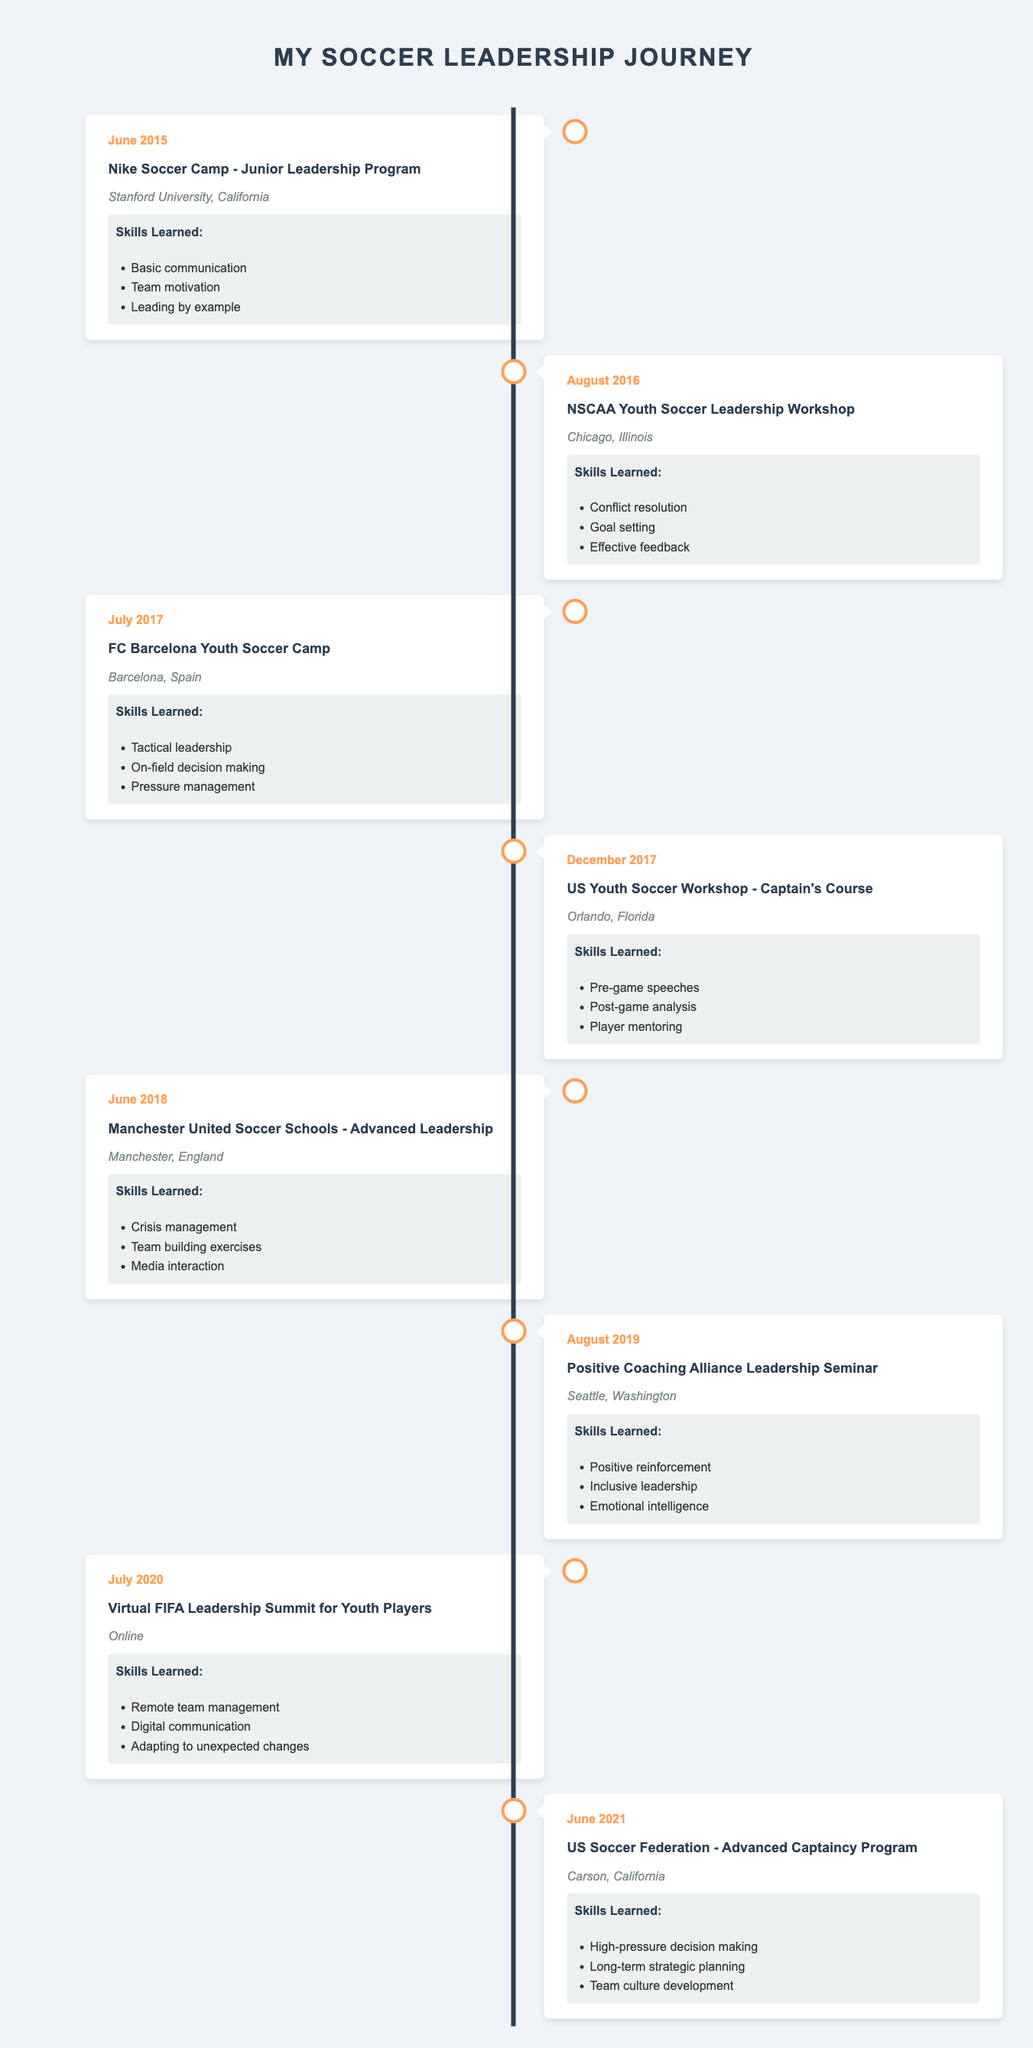What event took place in June 2015? The table indicates that the event in June 2015 was the "Nike Soccer Camp - Junior Leadership Program." This can be found in the first entry of the timeline table.
Answer: Nike Soccer Camp - Junior Leadership Program Which location hosted the FC Barcelona Youth Soccer Camp? According to the data in the timeline, the FC Barcelona Youth Soccer Camp was held in Barcelona, Spain. This information is available in the row corresponding to July 2017.
Answer: Barcelona, Spain How many different skills were learned during the Manchester United Soccer Schools - Advanced Leadership program? The program offered three distinct skills: Crisis management, Team building exercises, and Media interaction. This is outlined in the June 2018 entry of the timeline.
Answer: Three Was "Pressure management" one of the skills learned at the FC Barcelona Youth Soccer Camp? Yes, "Pressure management" is explicitly listed as one of the skills learned during this camp, found in the July 2017 entry of the timeline.
Answer: Yes What is the average number of skills learned per event from the timeline? To determine this, we first count the number of skills for each event: 3 (June 2015) + 3 (August 2016) + 3 (July 2017) + 3 (December 2017) + 3 (June 2018) + 3 (August 2019) + 3 (July 2020) + 3 (June 2021) = 24 skills total. There are 8 events, so the average is 24/8 = 3.
Answer: 3 